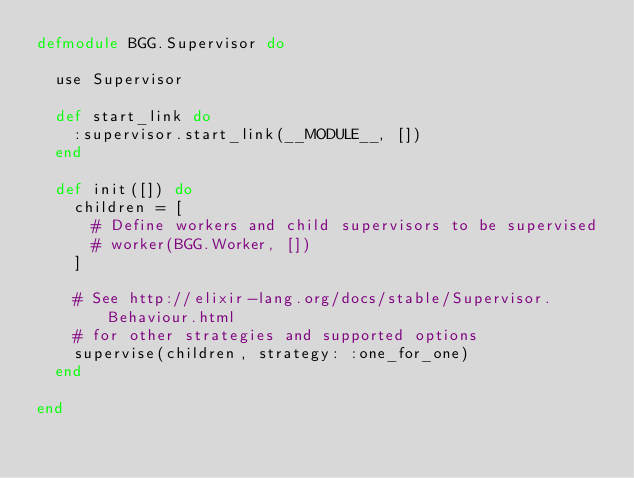Convert code to text. <code><loc_0><loc_0><loc_500><loc_500><_Elixir_>defmodule BGG.Supervisor do

  use Supervisor

  def start_link do
    :supervisor.start_link(__MODULE__, [])
  end

  def init([]) do
    children = [
      # Define workers and child supervisors to be supervised
      # worker(BGG.Worker, [])
    ]

    # See http://elixir-lang.org/docs/stable/Supervisor.Behaviour.html
    # for other strategies and supported options
    supervise(children, strategy: :one_for_one)
  end

end
</code> 